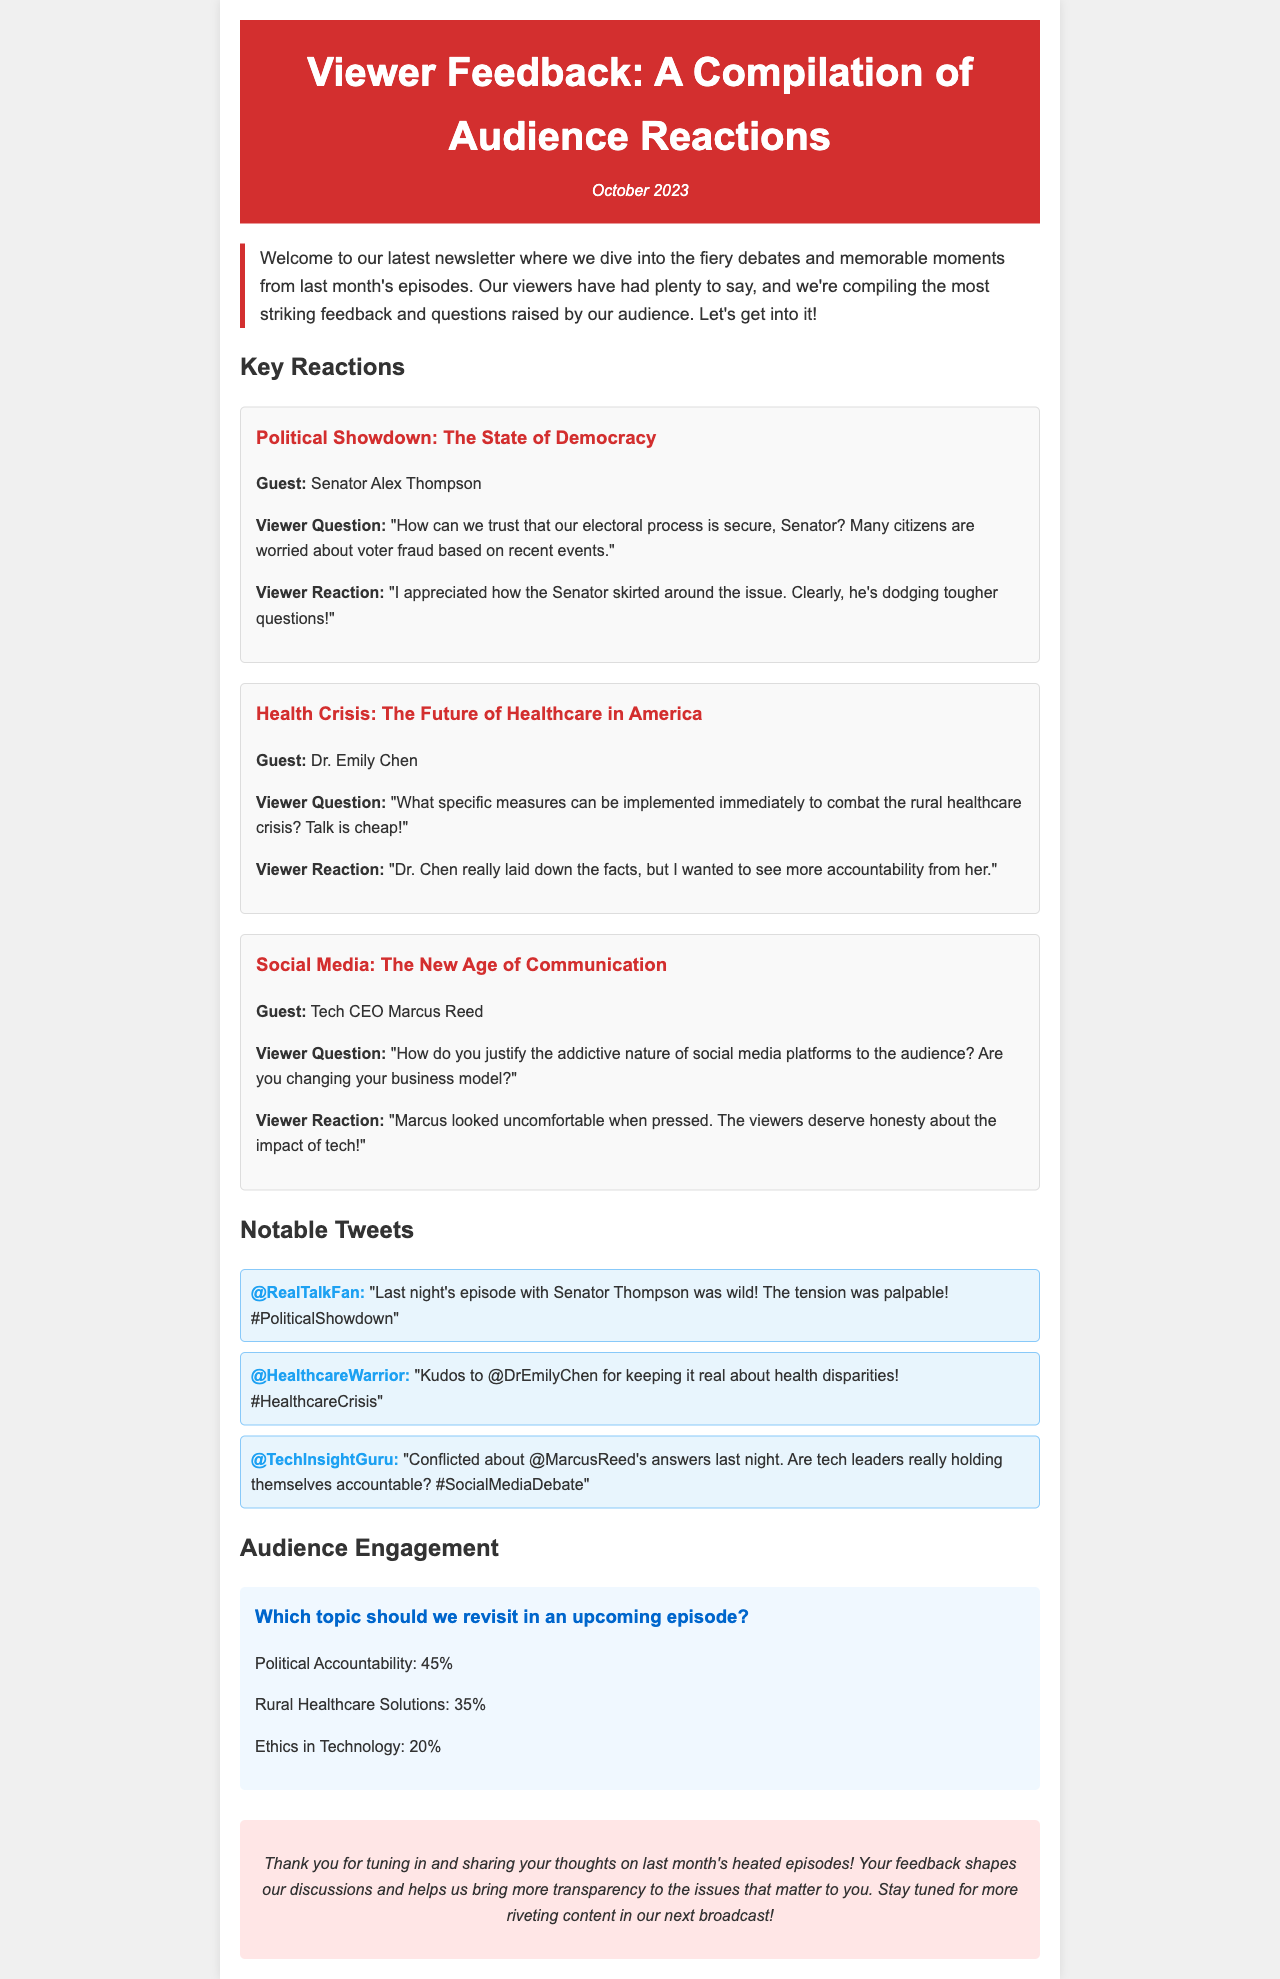What is the title of the newsletter? The title is stated at the top of the document in the header section.
Answer: Viewer Feedback: A Compilation of Audience Reactions What month is the newsletter covering? The month is indicated in the date section of the header.
Answer: October 2023 Who is the guest for the episode titled "Health Crisis: The Future of Healthcare in America"? The guest is mentioned directly under the title of that episode.
Answer: Dr. Emily Chen What percentage of voters want to revisit "Political Accountability"? The percentage is provided in the audience engagement poll section of the document.
Answer: 45% What specific viewer question was asked to Senator Alex Thompson? The viewer question is stated directly after the guest's name in the "Political Showdown" section.
Answer: "How can we trust that our electoral process is secure, Senator? Many citizens are worried about voter fraud based on recent events." Which tweet praises Dr. Emily Chen? The tweet is mentioned in the Notable Tweets section, identifying the user who praised her.
Answer: @HealthcareWarrior In what format is the viewer feedback presented? This is inferred from the structure and headings within the document.
Answer: Newsletter What is the viewer reaction to Marcus Reed's discomfort? This reaction is quoted under the "Social Media" episode feedback section.
Answer: "Marcus looked uncomfortable when pressed. The viewers deserve honesty about the impact of tech!" 